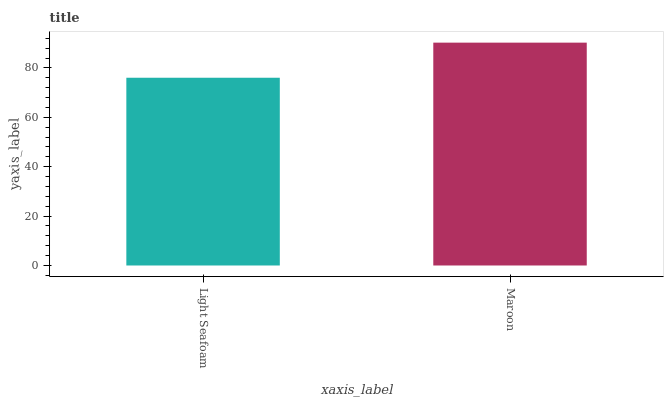Is Light Seafoam the minimum?
Answer yes or no. Yes. Is Maroon the maximum?
Answer yes or no. Yes. Is Maroon the minimum?
Answer yes or no. No. Is Maroon greater than Light Seafoam?
Answer yes or no. Yes. Is Light Seafoam less than Maroon?
Answer yes or no. Yes. Is Light Seafoam greater than Maroon?
Answer yes or no. No. Is Maroon less than Light Seafoam?
Answer yes or no. No. Is Maroon the high median?
Answer yes or no. Yes. Is Light Seafoam the low median?
Answer yes or no. Yes. Is Light Seafoam the high median?
Answer yes or no. No. Is Maroon the low median?
Answer yes or no. No. 